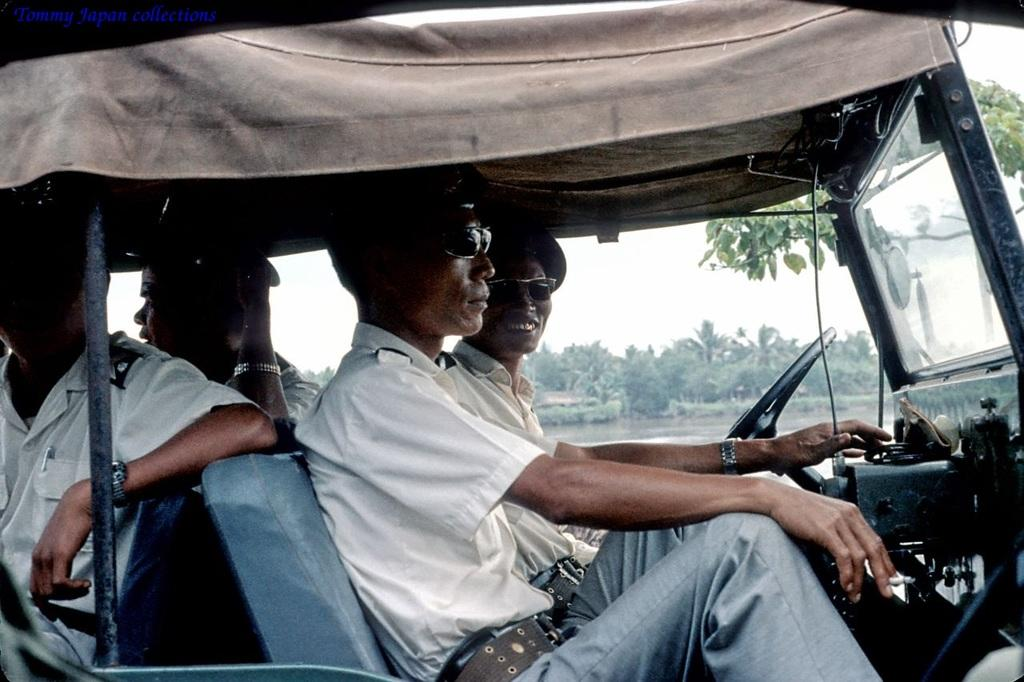What is the main subject of the image? There is a vehicle in the image. Who or what is inside the vehicle? There are people sitting in the vehicle. What are the people wearing? The people are wearing shirts and goggles. What can be seen in the background of the image? There is water, trees, and the sky visible in the background of the image. What type of stone is being used to play volleyball in the image? There is no stone or volleyball present in the image. Is there a hospital visible in the image? No, there is no hospital visible in the image; the image features a vehicle with people inside and a background with water, trees, and the sky. 